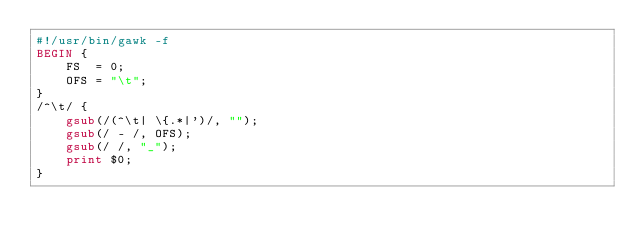Convert code to text. <code><loc_0><loc_0><loc_500><loc_500><_Awk_>#!/usr/bin/gawk -f
BEGIN {
    FS  = 0;
    OFS = "\t";
}
/^\t/ {
    gsub(/(^\t| \{.*|')/, "");
    gsub(/ - /, OFS);
    gsub(/ /, "_");
    print $0;
}
</code> 